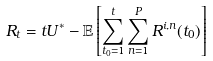<formula> <loc_0><loc_0><loc_500><loc_500>R _ { t } = t U ^ { * } - \mathbb { E } \left [ \sum _ { t _ { 0 } = 1 } ^ { t } \sum _ { n = 1 } ^ { P } R ^ { i , n } ( t _ { 0 } ) \right ]</formula> 